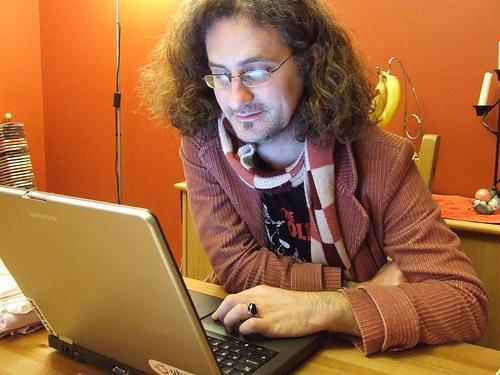How many bananas are there?
Give a very brief answer. 2. How many keyboards in the picture?
Give a very brief answer. 0. 